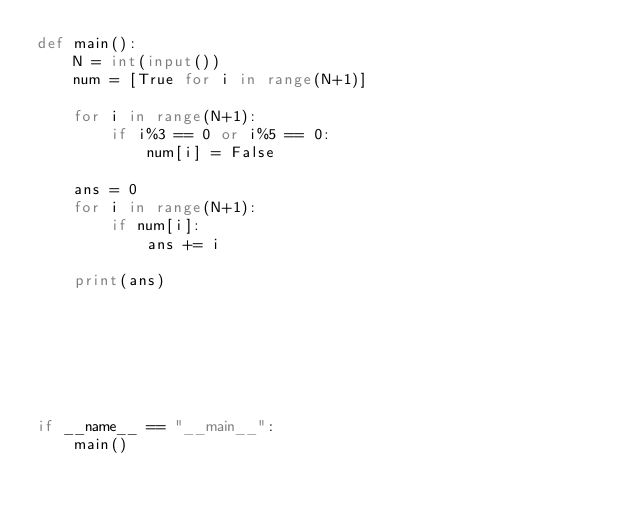<code> <loc_0><loc_0><loc_500><loc_500><_Python_>def main():
    N = int(input())
    num = [True for i in range(N+1)]
    
    for i in range(N+1):
        if i%3 == 0 or i%5 == 0:
            num[i] = False
    
    ans = 0
    for i in range(N+1):
        if num[i]:
            ans += i
    
    print(ans)
    
    
    
    
    
    
    
if __name__ == "__main__":
    main()
</code> 